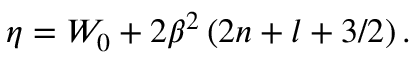Convert formula to latex. <formula><loc_0><loc_0><loc_500><loc_500>\eta = W _ { 0 } + 2 \beta ^ { 2 } \left ( 2 n + l + 3 / 2 \right ) .</formula> 